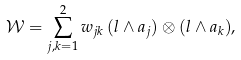<formula> <loc_0><loc_0><loc_500><loc_500>\mathcal { W } = \sum _ { j , k = 1 } ^ { 2 } w _ { j k } \, ( l \wedge a _ { j } ) \otimes ( l \wedge a _ { k } ) ,</formula> 